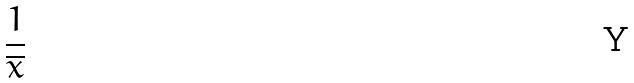Convert formula to latex. <formula><loc_0><loc_0><loc_500><loc_500>\frac { 1 } { \overline { x } }</formula> 